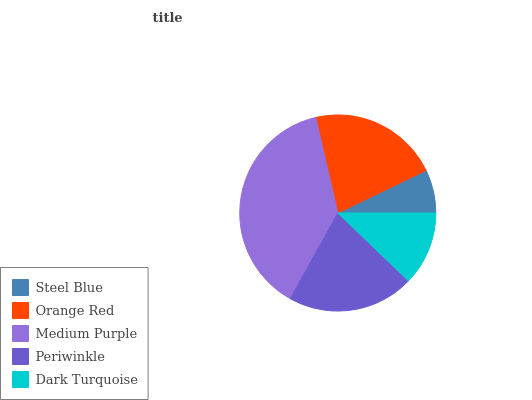Is Steel Blue the minimum?
Answer yes or no. Yes. Is Medium Purple the maximum?
Answer yes or no. Yes. Is Orange Red the minimum?
Answer yes or no. No. Is Orange Red the maximum?
Answer yes or no. No. Is Orange Red greater than Steel Blue?
Answer yes or no. Yes. Is Steel Blue less than Orange Red?
Answer yes or no. Yes. Is Steel Blue greater than Orange Red?
Answer yes or no. No. Is Orange Red less than Steel Blue?
Answer yes or no. No. Is Periwinkle the high median?
Answer yes or no. Yes. Is Periwinkle the low median?
Answer yes or no. Yes. Is Orange Red the high median?
Answer yes or no. No. Is Orange Red the low median?
Answer yes or no. No. 